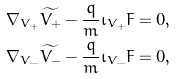Convert formula to latex. <formula><loc_0><loc_0><loc_500><loc_500>& \nabla _ { V _ { + } } \widetilde { V _ { + } } - \frac { q } { m } \iota _ { V _ { + } } F = 0 , \\ & \nabla _ { V _ { - } } \widetilde { V _ { - } } - \frac { q } { m } \iota _ { V _ { - } } F = 0 ,</formula> 